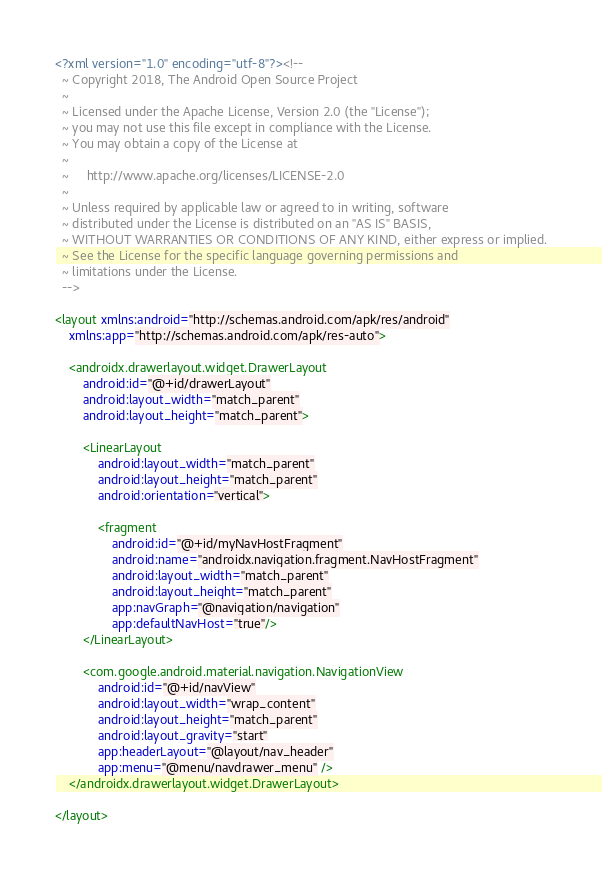Convert code to text. <code><loc_0><loc_0><loc_500><loc_500><_XML_><?xml version="1.0" encoding="utf-8"?><!--
  ~ Copyright 2018, The Android Open Source Project
  ~
  ~ Licensed under the Apache License, Version 2.0 (the "License");
  ~ you may not use this file except in compliance with the License.
  ~ You may obtain a copy of the License at
  ~
  ~     http://www.apache.org/licenses/LICENSE-2.0
  ~
  ~ Unless required by applicable law or agreed to in writing, software
  ~ distributed under the License is distributed on an "AS IS" BASIS,
  ~ WITHOUT WARRANTIES OR CONDITIONS OF ANY KIND, either express or implied.
  ~ See the License for the specific language governing permissions and
  ~ limitations under the License.
  -->

<layout xmlns:android="http://schemas.android.com/apk/res/android"
    xmlns:app="http://schemas.android.com/apk/res-auto">

    <androidx.drawerlayout.widget.DrawerLayout
        android:id="@+id/drawerLayout"
        android:layout_width="match_parent"
        android:layout_height="match_parent">

        <LinearLayout
            android:layout_width="match_parent"
            android:layout_height="match_parent"
            android:orientation="vertical">

            <fragment
                android:id="@+id/myNavHostFragment"
                android:name="androidx.navigation.fragment.NavHostFragment"
                android:layout_width="match_parent"
                android:layout_height="match_parent"
                app:navGraph="@navigation/navigation"
                app:defaultNavHost="true"/>
        </LinearLayout>

        <com.google.android.material.navigation.NavigationView
            android:id="@+id/navView"
            android:layout_width="wrap_content"
            android:layout_height="match_parent"
            android:layout_gravity="start"
            app:headerLayout="@layout/nav_header"
            app:menu="@menu/navdrawer_menu" />
    </androidx.drawerlayout.widget.DrawerLayout>

</layout>
</code> 